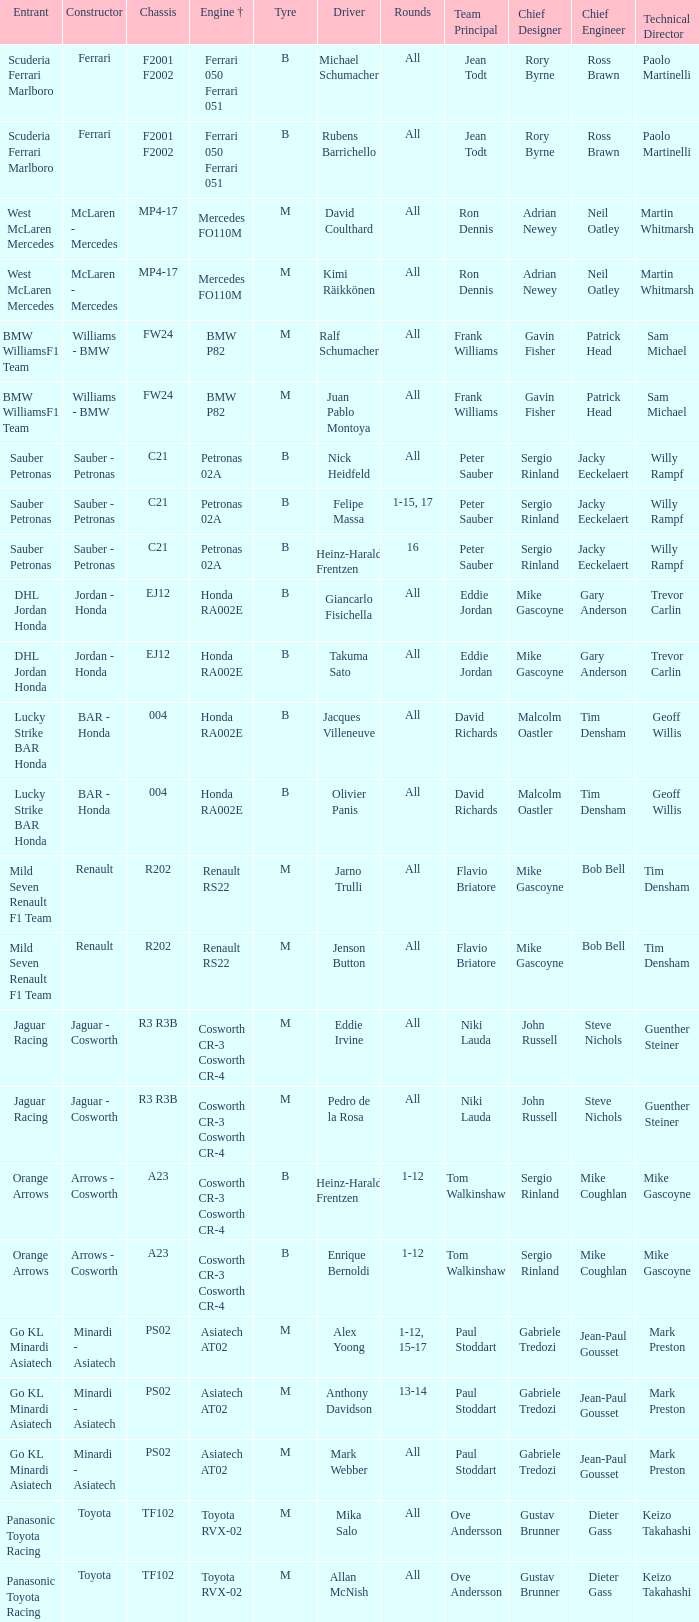What is the tyre when the engine is asiatech at02 and the driver is alex yoong? M. 